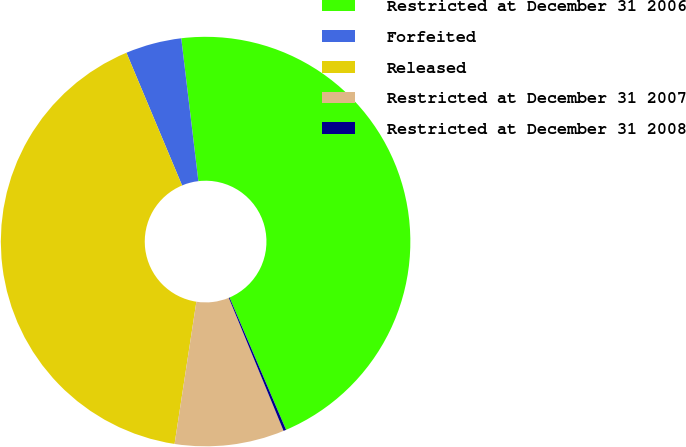<chart> <loc_0><loc_0><loc_500><loc_500><pie_chart><fcel>Restricted at December 31 2006<fcel>Forfeited<fcel>Released<fcel>Restricted at December 31 2007<fcel>Restricted at December 31 2008<nl><fcel>45.47%<fcel>4.42%<fcel>41.26%<fcel>8.64%<fcel>0.21%<nl></chart> 